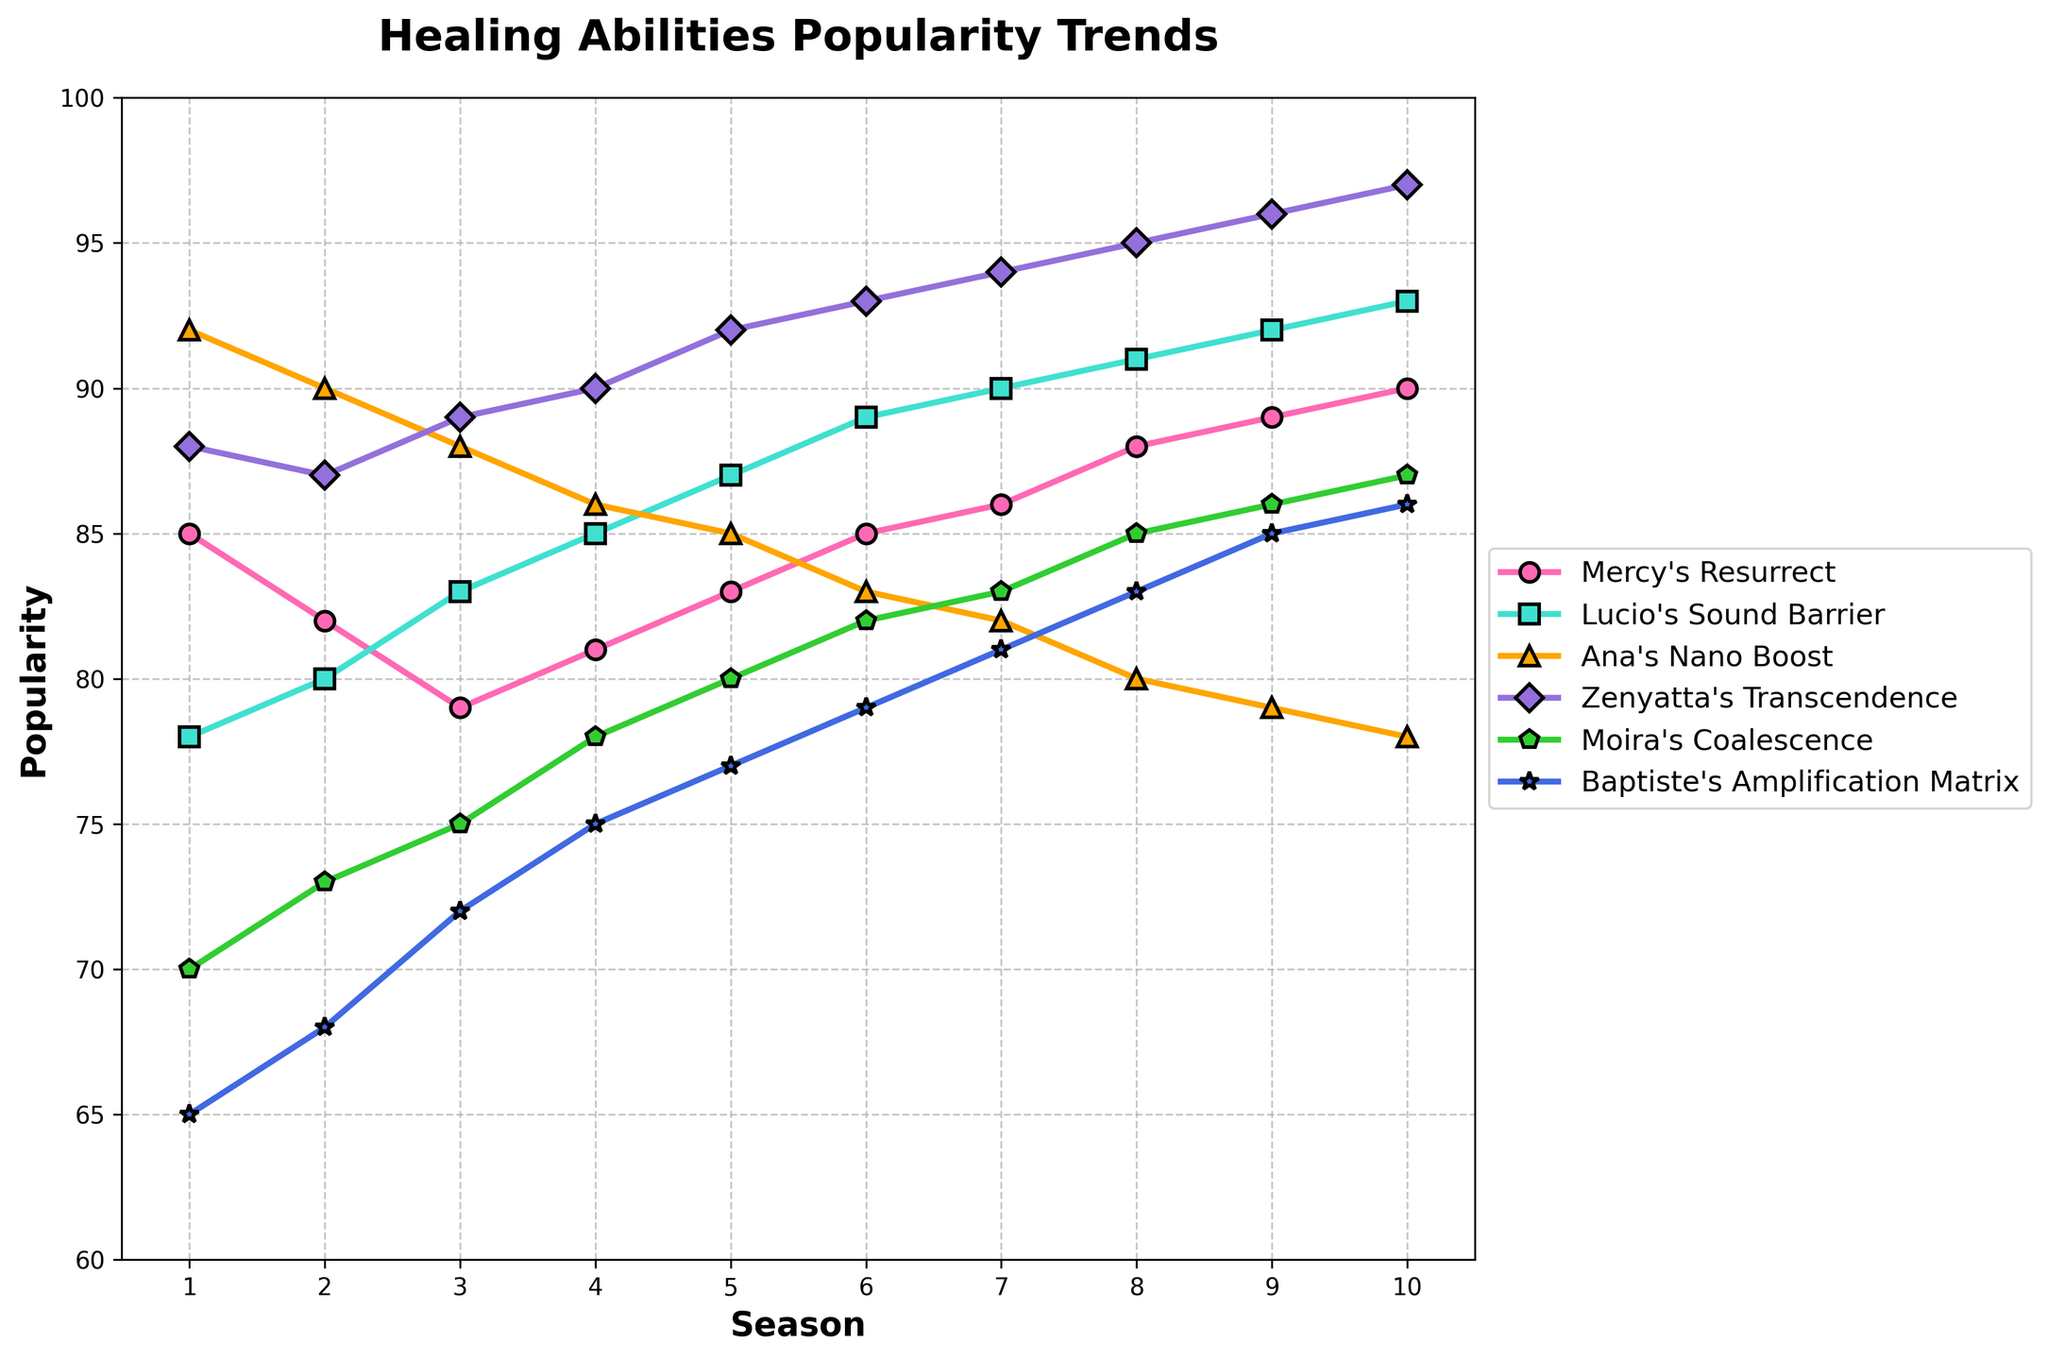Which healing ability had the highest popularity in Season 5? To determine this, locate Season 5 on the x-axis and find the highest point among all the plotted lines. The line for Zenyatta's Transcendence reaches the highest point in Season 5.
Answer: Zenyatta's Transcendence In which season did Mercy's Resurrect and Zenyatta's Transcendence have the same popularity? Look for the two lines representing Mercy's Resurrect and Zenyatta's Transcendence and find the season where they intersect. They intersect in Season 1.
Answer: Season 1 By how much did Lucio's Sound Barrier popularity change from Season 1 to Season 10? Find the y-values for Lucio's Sound Barrier at Season 1 and Season 10 and subtract the former from the latter. The values are 78 and 93, respectively; thus, the change is 93 - 78.
Answer: 15 Which healing ability had the most consistent popularity trend over the 10 seasons? To determine this, observe the lines and identify the one with the least variation (flattest slope). Baptiste's Amplification Matrix shows the most consistent trend over the seasons.
Answer: Baptiste's Amplification Matrix Compare the popularity of Moira's Coalescence in Season 2 and Season 8. Which season had higher popularity and by how much? Find the y-values for Moira's Coalescence in Seasons 2 and 8 (73 and 85, respectively) and subtract the lower value from the higher one.
Answer: Season 8, by 12 What is the average popularity of Mercy's Resurrect over all seasons? Sum the popularity values of Mercy's Resurrect across all seasons and divide by the number of seasons (85 + 82 + 79 + 81 + 83 + 85 + 86 + 88 + 89 + 90 = 848; 848/10).
Answer: 84.8 During which season was the difference in popularity between Ana's Nano Boost and Zenyatta's Transcendence the smallest? Calculate the difference between Ana's Nano Boost and Zenyatta's Transcendence for each season and identify the smallest value. Minimum difference occurs in Season 3 (89 - 88 = 1).
Answer: Season 3 How many abilities show an upward trend in popularity from Season 1 to Season 10? Observe each ability's starting and ending popularity (Season 1 to Season 10); count those with an increase. Five abilities show an upward trend: Mercy's Resurrect, Lucio's Sound Barrier, Zenyatta's Transcendence, Moira's Coalescence, and Baptiste's Amplification Matrix. Ana's Nano Boost trends downward.
Answer: Five abilities What is the combined popularity of Lucio's Sound Barrier and Mercy's Resurrect in Season 4? Add the popularity values of Lucio's Sound Barrier and Mercy's Resurrect in Season 4 (85 and 81).
Answer: 166 During which two consecutive seasons did Zenyatta's Transcendence see the largest increase in popularity? Calculate the increase between each pair of consecutive seasons for Zenyatta's Transcendence, and find the largest. The largest increase is from Season 4 to Season 5 (92 - 90 = 2).
Answer: Seasons 5 and 6 